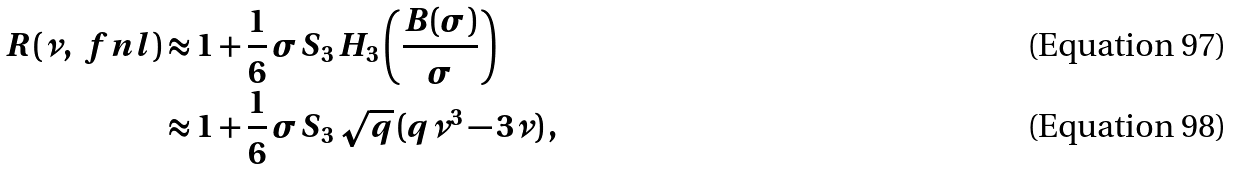Convert formula to latex. <formula><loc_0><loc_0><loc_500><loc_500>R ( \nu , \ f n l ) & \approx 1 + \frac { 1 } { 6 } \, \sigma S _ { 3 } \, H _ { 3 } \left ( \frac { B ( \sigma ) } { \sigma } \right ) \\ & \approx 1 + \frac { 1 } { 6 } \, \sigma S _ { 3 } \, \sqrt { q } \, ( q \nu ^ { 3 } - 3 \nu ) \, ,</formula> 